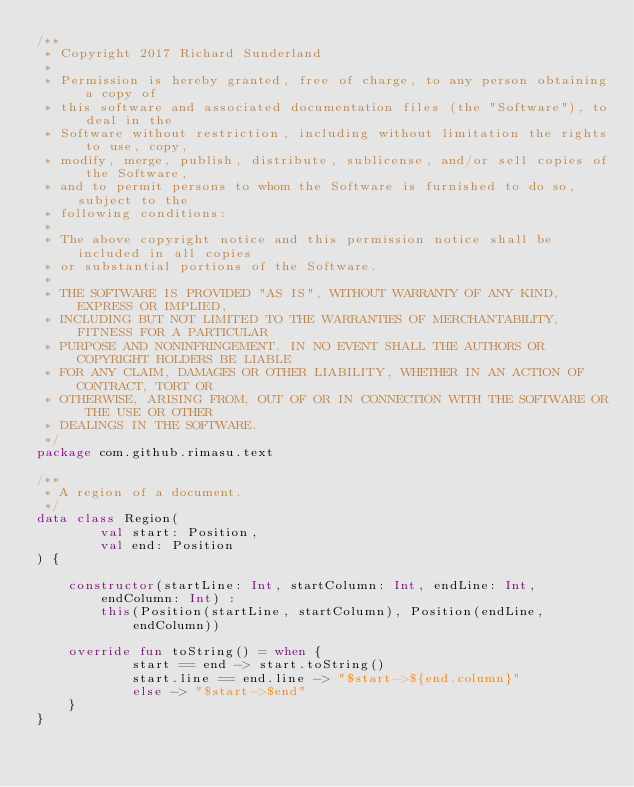Convert code to text. <code><loc_0><loc_0><loc_500><loc_500><_Kotlin_>/**
 * Copyright 2017 Richard Sunderland
 *
 * Permission is hereby granted, free of charge, to any person obtaining a copy of
 * this software and associated documentation files (the "Software"), to deal in the
 * Software without restriction, including without limitation the rights to use, copy,
 * modify, merge, publish, distribute, sublicense, and/or sell copies of the Software,
 * and to permit persons to whom the Software is furnished to do so, subject to the
 * following conditions:
 *
 * The above copyright notice and this permission notice shall be included in all copies
 * or substantial portions of the Software.
 *
 * THE SOFTWARE IS PROVIDED "AS IS", WITHOUT WARRANTY OF ANY KIND, EXPRESS OR IMPLIED,
 * INCLUDING BUT NOT LIMITED TO THE WARRANTIES OF MERCHANTABILITY, FITNESS FOR A PARTICULAR
 * PURPOSE AND NONINFRINGEMENT. IN NO EVENT SHALL THE AUTHORS OR COPYRIGHT HOLDERS BE LIABLE
 * FOR ANY CLAIM, DAMAGES OR OTHER LIABILITY, WHETHER IN AN ACTION OF CONTRACT, TORT OR
 * OTHERWISE, ARISING FROM, OUT OF OR IN CONNECTION WITH THE SOFTWARE OR THE USE OR OTHER
 * DEALINGS IN THE SOFTWARE.
 */
package com.github.rimasu.text

/**
 * A region of a document.
 */
data class Region(
        val start: Position,
        val end: Position
) {

    constructor(startLine: Int, startColumn: Int, endLine: Int, endColumn: Int) :
        this(Position(startLine, startColumn), Position(endLine, endColumn))

    override fun toString() = when {
            start == end -> start.toString()
            start.line == end.line -> "$start->${end.column}"
            else -> "$start->$end"
    }
}</code> 